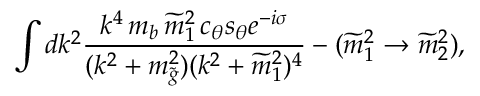<formula> <loc_0><loc_0><loc_500><loc_500>\int d k ^ { 2 } { \frac { k ^ { 4 } \, m _ { b } \, \widetilde { m } _ { 1 } ^ { 2 } \, c _ { \theta } s _ { \theta } e ^ { - i \sigma } } { ( k ^ { 2 } + m _ { \tilde { g } } ^ { 2 } ) ( k ^ { 2 } + \widetilde { m } _ { 1 } ^ { 2 } ) ^ { 4 } } } - ( \widetilde { m } _ { 1 } ^ { 2 } \to \widetilde { m } _ { 2 } ^ { 2 } ) ,</formula> 